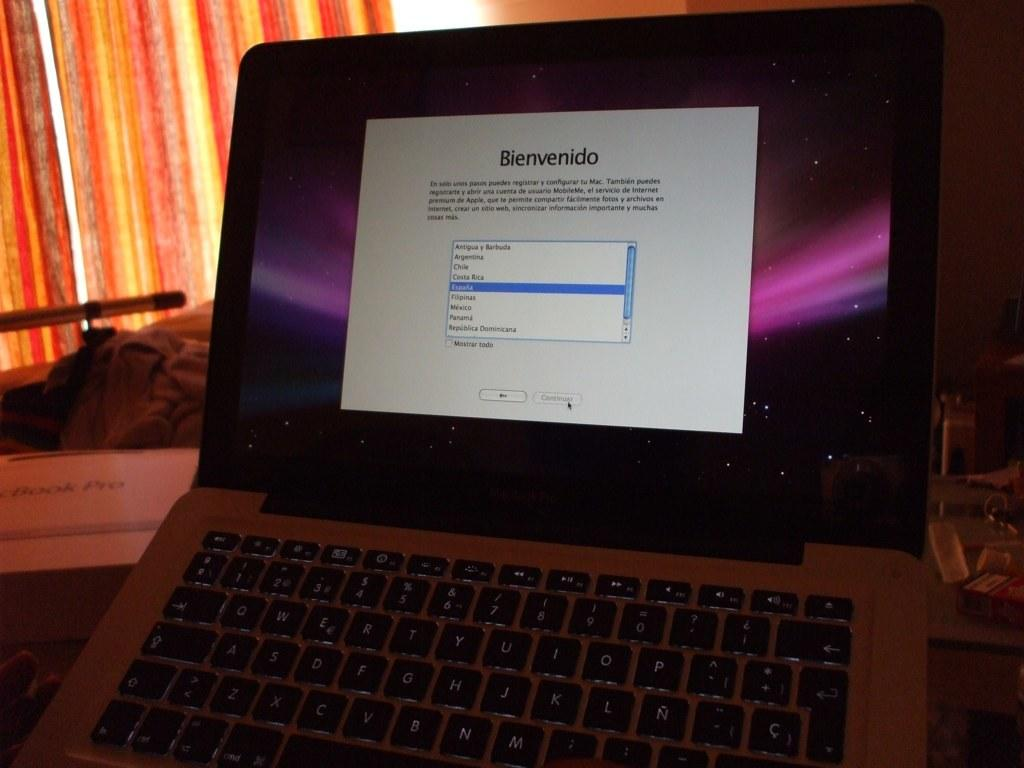<image>
Create a compact narrative representing the image presented. A computer shows a setup screen and reads Bienvenido. 